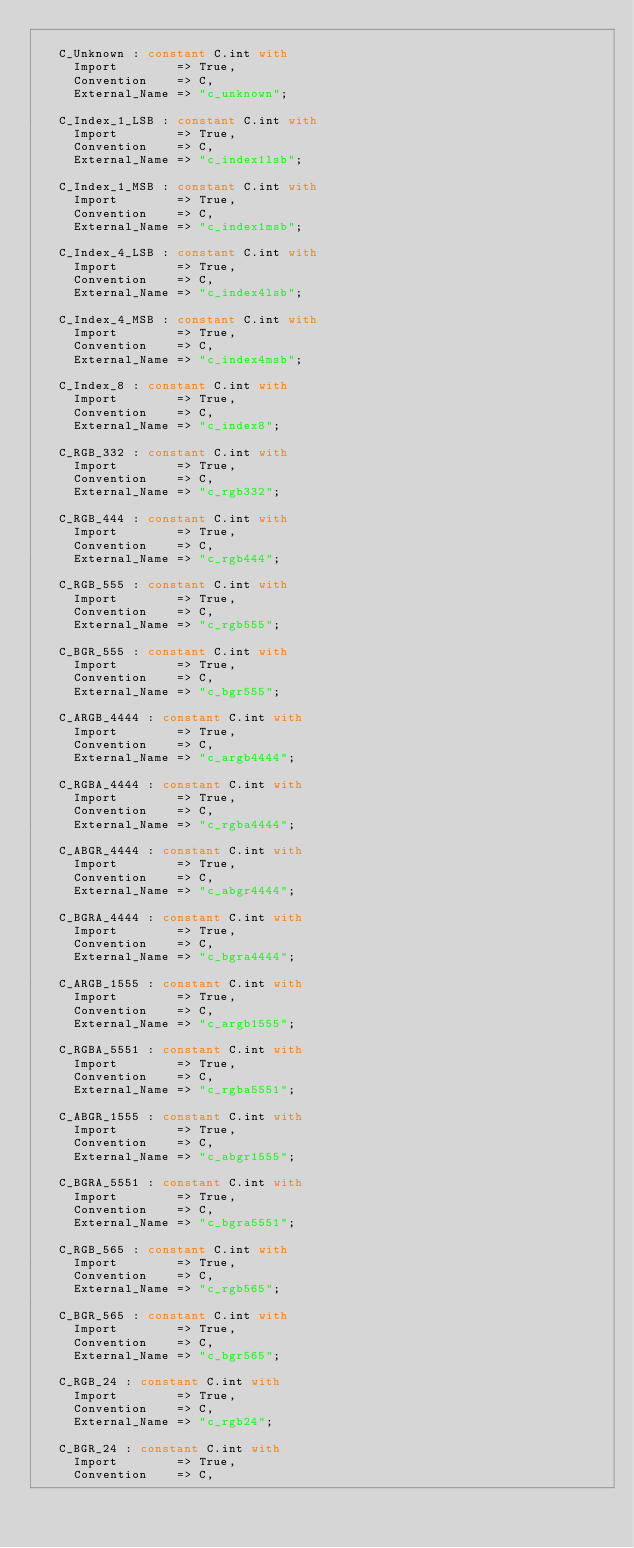<code> <loc_0><loc_0><loc_500><loc_500><_Ada_>
   C_Unknown : constant C.int with
     Import        => True,
     Convention    => C,
     External_Name => "c_unknown";

   C_Index_1_LSB : constant C.int with
     Import        => True,
     Convention    => C,
     External_Name => "c_index1lsb";

   C_Index_1_MSB : constant C.int with
     Import        => True,
     Convention    => C,
     External_Name => "c_index1msb";

   C_Index_4_LSB : constant C.int with
     Import        => True,
     Convention    => C,
     External_Name => "c_index4lsb";

   C_Index_4_MSB : constant C.int with
     Import        => True,
     Convention    => C,
     External_Name => "c_index4msb";

   C_Index_8 : constant C.int with
     Import        => True,
     Convention    => C,
     External_Name => "c_index8";

   C_RGB_332 : constant C.int with
     Import        => True,
     Convention    => C,
     External_Name => "c_rgb332";

   C_RGB_444 : constant C.int with
     Import        => True,
     Convention    => C,
     External_Name => "c_rgb444";

   C_RGB_555 : constant C.int with
     Import        => True,
     Convention    => C,
     External_Name => "c_rgb555";

   C_BGR_555 : constant C.int with
     Import        => True,
     Convention    => C,
     External_Name => "c_bgr555";

   C_ARGB_4444 : constant C.int with
     Import        => True,
     Convention    => C,
     External_Name => "c_argb4444";

   C_RGBA_4444 : constant C.int with
     Import        => True,
     Convention    => C,
     External_Name => "c_rgba4444";

   C_ABGR_4444 : constant C.int with
     Import        => True,
     Convention    => C,
     External_Name => "c_abgr4444";

   C_BGRA_4444 : constant C.int with
     Import        => True,
     Convention    => C,
     External_Name => "c_bgra4444";

   C_ARGB_1555 : constant C.int with
     Import        => True,
     Convention    => C,
     External_Name => "c_argb1555";

   C_RGBA_5551 : constant C.int with
     Import        => True,
     Convention    => C,
     External_Name => "c_rgba5551";

   C_ABGR_1555 : constant C.int with
     Import        => True,
     Convention    => C,
     External_Name => "c_abgr1555";

   C_BGRA_5551 : constant C.int with
     Import        => True,
     Convention    => C,
     External_Name => "c_bgra5551";

   C_RGB_565 : constant C.int with
     Import        => True,
     Convention    => C,
     External_Name => "c_rgb565";

   C_BGR_565 : constant C.int with
     Import        => True,
     Convention    => C,
     External_Name => "c_bgr565";

   C_RGB_24 : constant C.int with
     Import        => True,
     Convention    => C,
     External_Name => "c_rgb24";

   C_BGR_24 : constant C.int with
     Import        => True,
     Convention    => C,</code> 